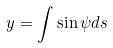<formula> <loc_0><loc_0><loc_500><loc_500>y = \int \sin \psi d s</formula> 